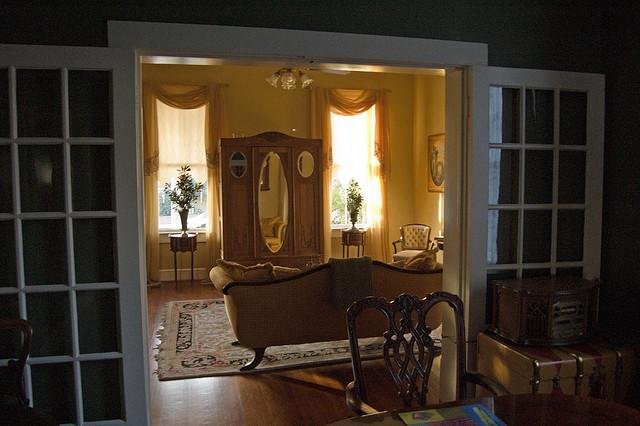What is at the far end of the room? Please explain your reasoning. mirror. A reflection of the room is being shown through that object. 